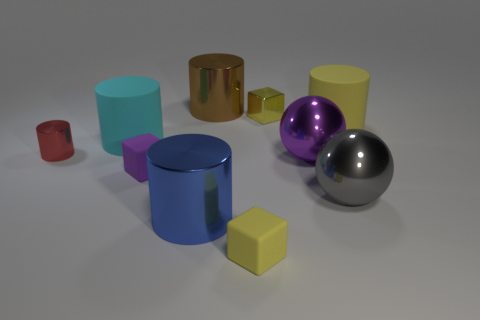How many other big objects are the same shape as the big gray object?
Offer a terse response. 1. The purple block that is made of the same material as the big yellow object is what size?
Offer a terse response. Small. Are there more tiny red metal objects than large brown rubber cubes?
Make the answer very short. Yes. There is a big cylinder that is in front of the tiny red metallic object; what color is it?
Keep it short and to the point. Blue. What is the size of the yellow thing that is both to the left of the large gray sphere and behind the large blue cylinder?
Provide a short and direct response. Small. What number of cyan metallic cylinders are the same size as the cyan rubber thing?
Your answer should be very brief. 0. There is another big thing that is the same shape as the big purple metal object; what is its material?
Ensure brevity in your answer.  Metal. Does the large gray thing have the same shape as the brown object?
Your answer should be compact. No. How many big matte cylinders are behind the blue thing?
Offer a very short reply. 2. The large object that is behind the small shiny thing that is right of the red cylinder is what shape?
Your answer should be compact. Cylinder. 